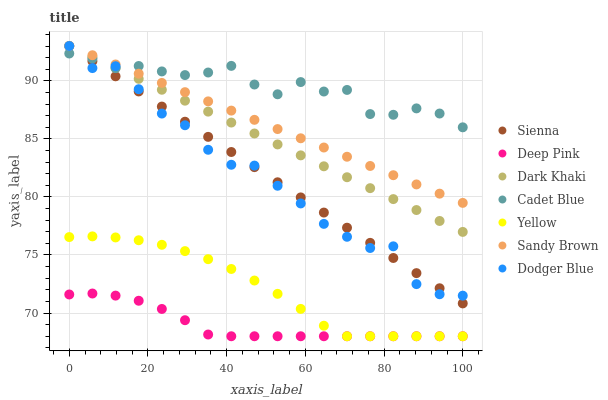Does Deep Pink have the minimum area under the curve?
Answer yes or no. Yes. Does Cadet Blue have the maximum area under the curve?
Answer yes or no. Yes. Does Yellow have the minimum area under the curve?
Answer yes or no. No. Does Yellow have the maximum area under the curve?
Answer yes or no. No. Is Dark Khaki the smoothest?
Answer yes or no. Yes. Is Dodger Blue the roughest?
Answer yes or no. Yes. Is Deep Pink the smoothest?
Answer yes or no. No. Is Deep Pink the roughest?
Answer yes or no. No. Does Deep Pink have the lowest value?
Answer yes or no. Yes. Does Sienna have the lowest value?
Answer yes or no. No. Does Sandy Brown have the highest value?
Answer yes or no. Yes. Does Yellow have the highest value?
Answer yes or no. No. Is Yellow less than Sandy Brown?
Answer yes or no. Yes. Is Sienna greater than Deep Pink?
Answer yes or no. Yes. Does Sienna intersect Dodger Blue?
Answer yes or no. Yes. Is Sienna less than Dodger Blue?
Answer yes or no. No. Is Sienna greater than Dodger Blue?
Answer yes or no. No. Does Yellow intersect Sandy Brown?
Answer yes or no. No. 